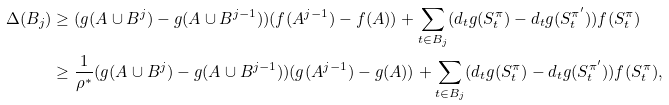Convert formula to latex. <formula><loc_0><loc_0><loc_500><loc_500>\Delta ( B _ { j } ) & \geq ( g ( A \cup B ^ { j } ) - g ( A \cup B ^ { j - 1 } ) ) ( f ( A ^ { j - 1 } ) - f ( A ) ) + \sum _ { t \in B _ { j } } ( d _ { t } g ( S _ { t } ^ { \pi } ) - d _ { t } g ( S _ { t } ^ { \pi ^ { \prime } } ) ) f ( S _ { t } ^ { \pi } ) \\ & \geq \frac { 1 } { \rho ^ { * } } ( g ( A \cup B ^ { j } ) - g ( A \cup B ^ { j - 1 } ) ) ( g ( A ^ { j - 1 } ) - g ( A ) ) + \sum _ { t \in B _ { j } } ( d _ { t } g ( S _ { t } ^ { \pi } ) - d _ { t } g ( S _ { t } ^ { \pi ^ { \prime } } ) ) f ( S _ { t } ^ { \pi } ) ,</formula> 